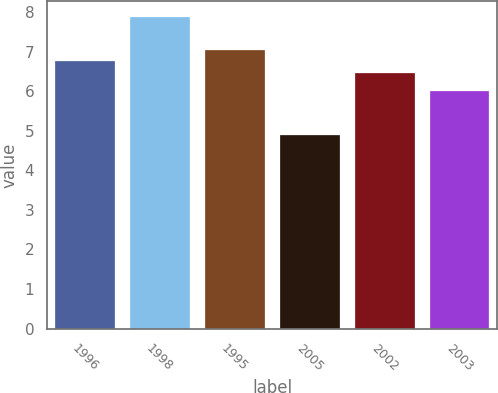Convert chart. <chart><loc_0><loc_0><loc_500><loc_500><bar_chart><fcel>1996<fcel>1998<fcel>1995<fcel>2005<fcel>2002<fcel>2003<nl><fcel>6.75<fcel>7.88<fcel>7.05<fcel>4.88<fcel>6.45<fcel>6<nl></chart> 